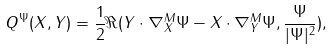<formula> <loc_0><loc_0><loc_500><loc_500>Q ^ { \Psi } ( X , Y ) = \frac { 1 } { 2 } \Re ( Y \cdot \nabla _ { X } ^ { M } \Psi - X \cdot \nabla _ { Y } ^ { M } \Psi , \frac { \Psi } { | \Psi | ^ { 2 } } ) ,</formula> 